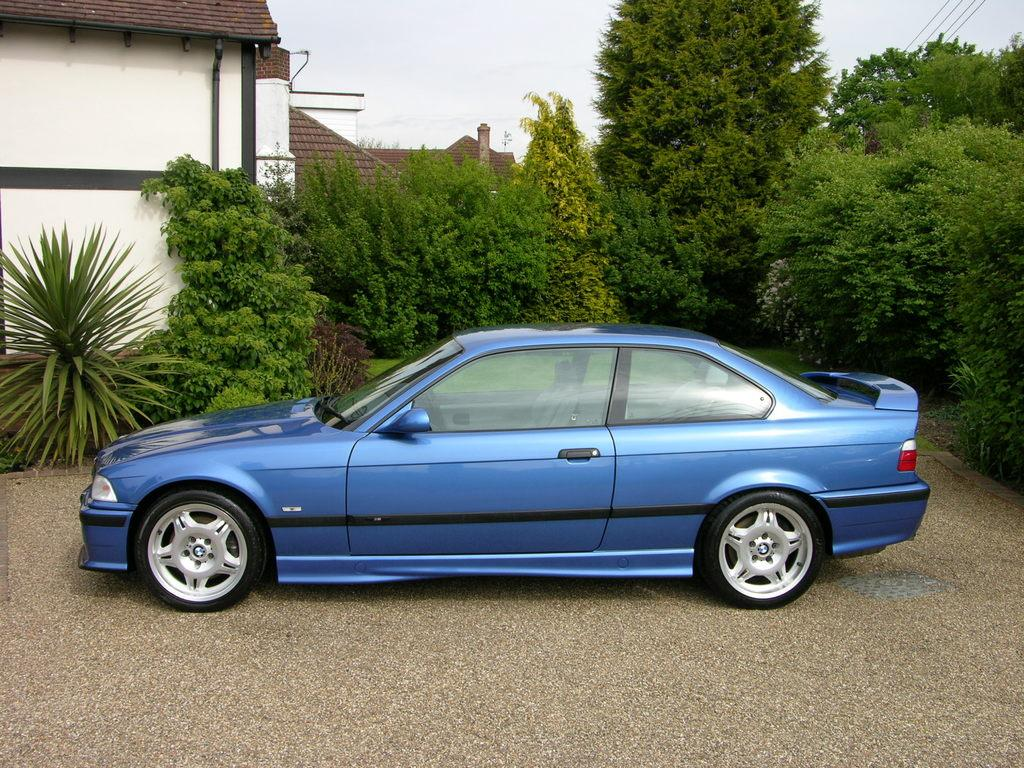What color is the car in the image? The car in the image is blue. Where is the car located in the image? The car is on the ground. What can be seen in the background of the image? In the background of the image, there are trees, plants, wires, the sky, houses, and other objects. What is the cause of the lizards climbing the trees in the image? There are no lizards present in the image, so it is not possible to determine the cause of their actions. 